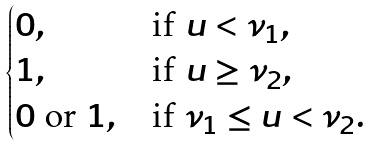Convert formula to latex. <formula><loc_0><loc_0><loc_500><loc_500>\begin{cases} 0 , & \text {if} \ u < \nu _ { 1 } , \\ 1 , & \text {if} \ u \geq \nu _ { 2 } , \\ 0 \ \text {or} \ 1 , & \text {if} \ \nu _ { 1 } \leq u < \nu _ { 2 } . \end{cases}</formula> 